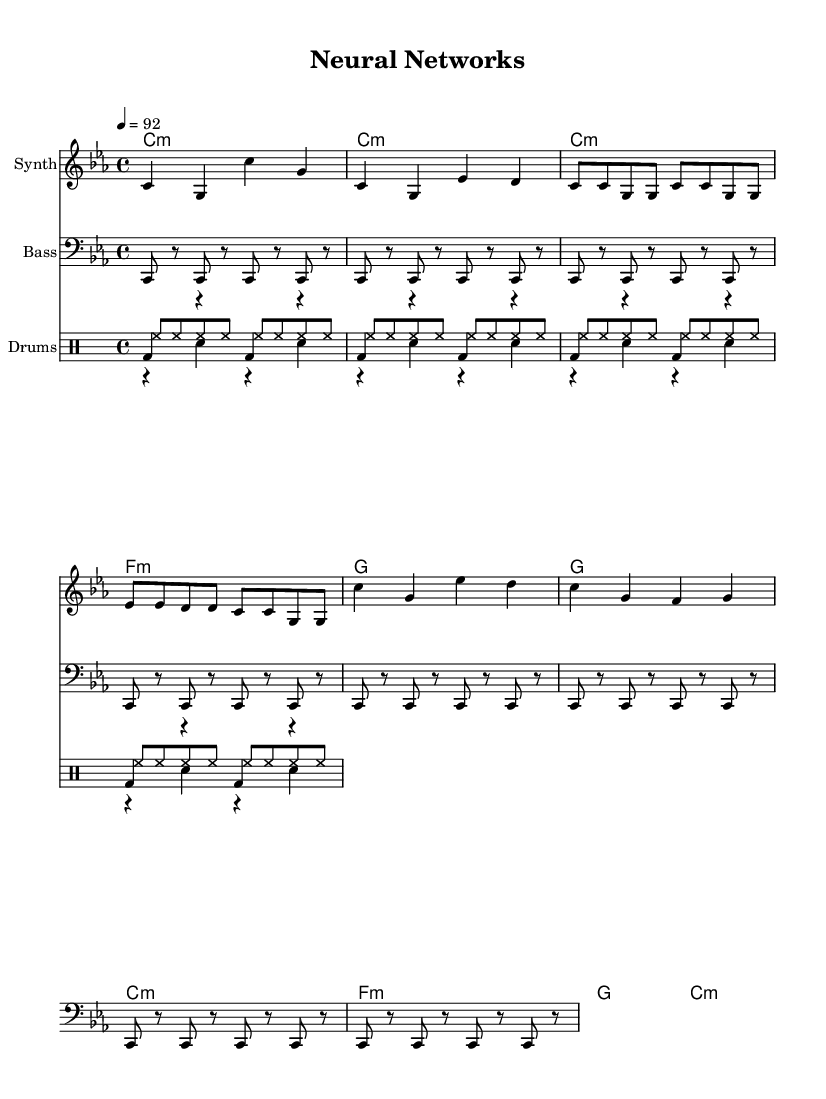What is the key signature of this music? The key signature is C minor, indicated by the presence of three flats (B♭, E♭, A♭) in the key signature area shown in the sheet music.
Answer: C minor What is the time signature of the piece? The time signature shown at the beginning of the staff is 4/4, which indicates that each measure contains four beats and that the quarter note gets one beat.
Answer: 4/4 What is the tempo marking in this sheet music? The tempo marking indicates a speed of 92 beats per minute, which is typical for a moderately fast rap track and is noted in the tempo section of the score.
Answer: 92 How many measures are in the chorus section? The chorus section is represented by a total of two measures, as indicated by the counting of the bar lines within the labeled chorus area of the music.
Answer: 2 What's the pattern of the bass line? The bass line repeats the note C in eighth note patterns, distinguished by the rhythm shown throughout the bottom staff, indicating a consistent underpinning that complements the melody.
Answer: C8 Which instruments are involved in the score? The score features a Synth for the melody, Bass for the lower harmony, and Drums comprising kick, snare, and hi-hat patterns for rhythm, which are clearly labeled at the beginning of each staff.
Answer: Synth, Bass, Drums What is the starting note of the melody? The starting note of the melody is C, which is indicated as the first note in the melody line of the sheet music.
Answer: C 